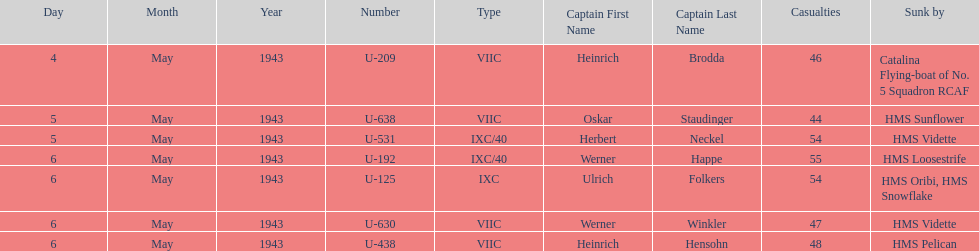Which u-boat was the first to sink U-209. 